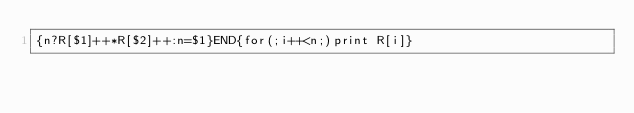<code> <loc_0><loc_0><loc_500><loc_500><_Awk_>{n?R[$1]++*R[$2]++:n=$1}END{for(;i++<n;)print R[i]}</code> 